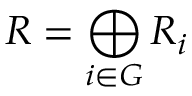Convert formula to latex. <formula><loc_0><loc_0><loc_500><loc_500>R = \bigoplus _ { i \in G } R _ { i }</formula> 